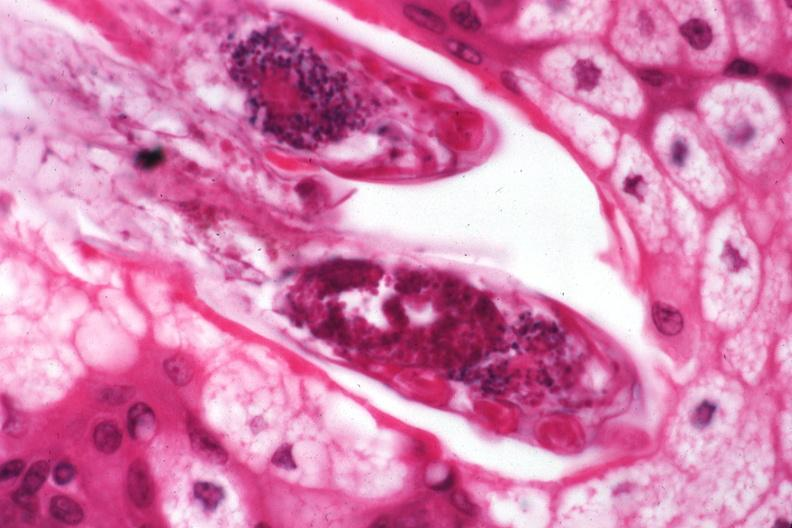does this image show demodex folliculorum?
Answer the question using a single word or phrase. Yes 